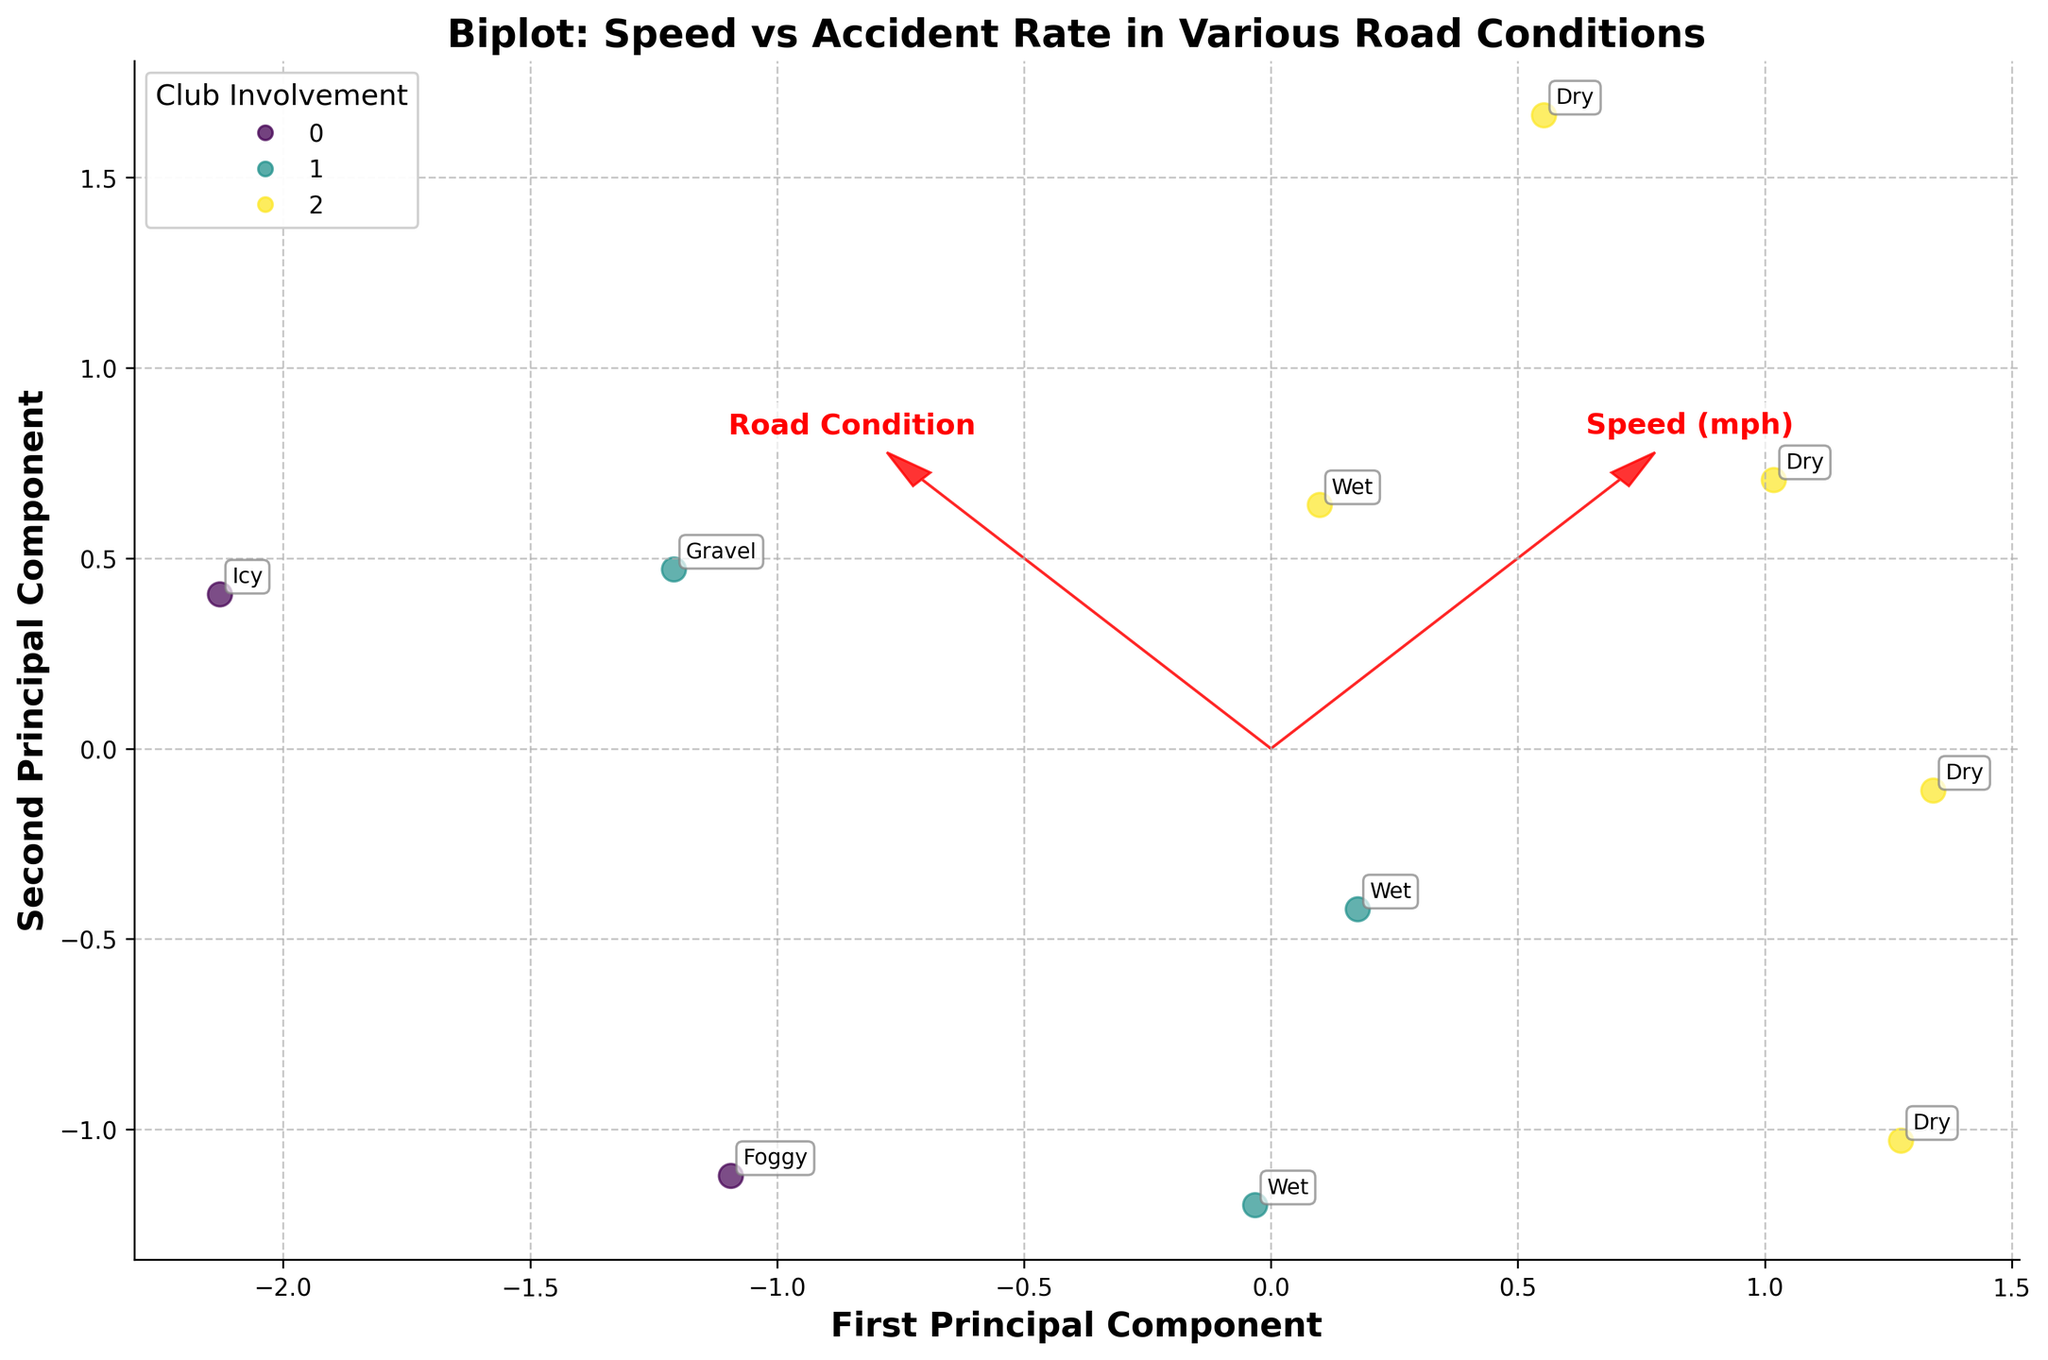What is the title of the figure? The title of the figure is found at the top and it summarizes what the plot is about.
Answer: Biplot: Speed vs Accident Rate in Various Road Conditions How is "Club Involvement" represented in the plot? "Club Involvement" is represented by the color of the data points, with different colors indicating different levels: Low, Medium, and High.
Answer: By color Which road condition has the highest accident rate? We can determine this by looking at the annotated data points and finding the one furthest along the accident rate axis.
Answer: Icy Which road condition corresponds to the highest speed? This can be found by identifying the data point with the label representing the highest speed value.
Answer: Dry (at 95 mph) What are the principal components and what do they represent? The principal components are represented by the axes labeled 'First Principal Component' and 'Second Principal Component'; they show the directions of maximum variance in the data after standardization.
Answer: Directions of maximum variance Which direction does the "Speed (mph)" vector point? The direction of the "Speed (mph)" vector is indicated by the red arrow on the plot.
Answer: Mostly horizontal How do wet and dry road conditions compare in terms of accident rate? Compare the annotated labels for "Wet" and "Dry" road conditions along the accident rate axis.
Answer: Wet has a higher accident rate on average Which road condition is associated with the lowest accident rate? Identifying the point with the smallest value along the accident rate axis will give the answer.
Answer: Dry (at 75 mph) What can be inferred about the relationship between speed and accident rate? By observing the overall positioning and direction of the "Speed" and "Accident Rate" vectors, we can infer if they are positively or negatively correlated.
Answer: Positive correlation What is the proportion of "High" club involvement points compared to the total number of points? Count the number of points colored to represent "High" and compare it to the total number.
Answer: High: 5 out of 10 points 